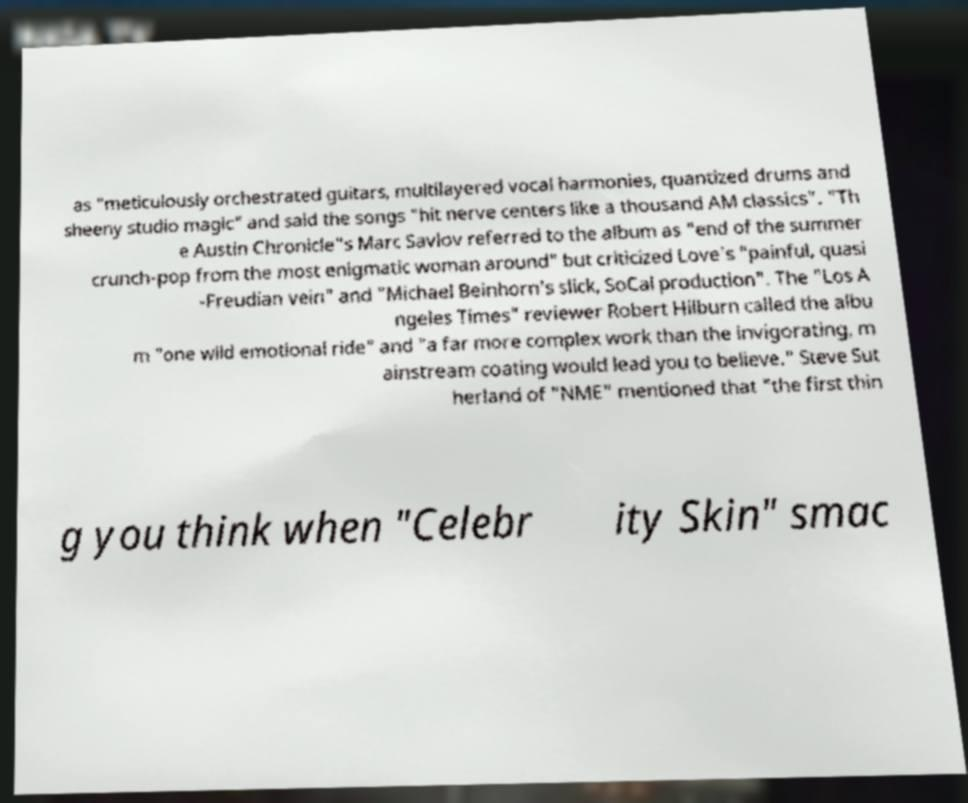There's text embedded in this image that I need extracted. Can you transcribe it verbatim? as "meticulously orchestrated guitars, multilayered vocal harmonies, quantized drums and sheeny studio magic" and said the songs "hit nerve centers like a thousand AM classics". "Th e Austin Chronicle"s Marc Savlov referred to the album as "end of the summer crunch-pop from the most enigmatic woman around" but criticized Love's "painful, quasi -Freudian vein" and "Michael Beinhorn's slick, SoCal production". The "Los A ngeles Times" reviewer Robert Hilburn called the albu m "one wild emotional ride" and "a far more complex work than the invigorating, m ainstream coating would lead you to believe." Steve Sut herland of "NME" mentioned that "the first thin g you think when "Celebr ity Skin" smac 